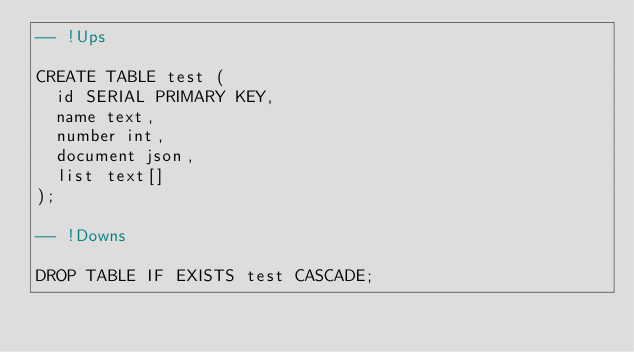Convert code to text. <code><loc_0><loc_0><loc_500><loc_500><_SQL_>-- !Ups

CREATE TABLE test (
  id SERIAL PRIMARY KEY,
  name text,
  number int,
  document json,
  list text[]
);

-- !Downs

DROP TABLE IF EXISTS test CASCADE;
</code> 